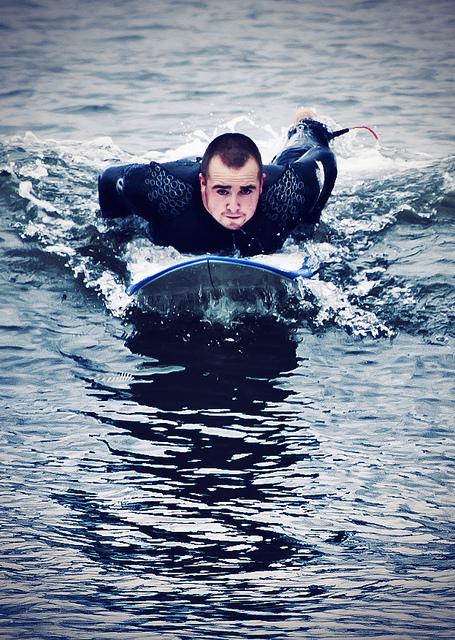Is this man laying down?
Give a very brief answer. Yes. Is the man about to drown?
Write a very short answer. No. What is the man floating on?
Be succinct. Surfboard. 